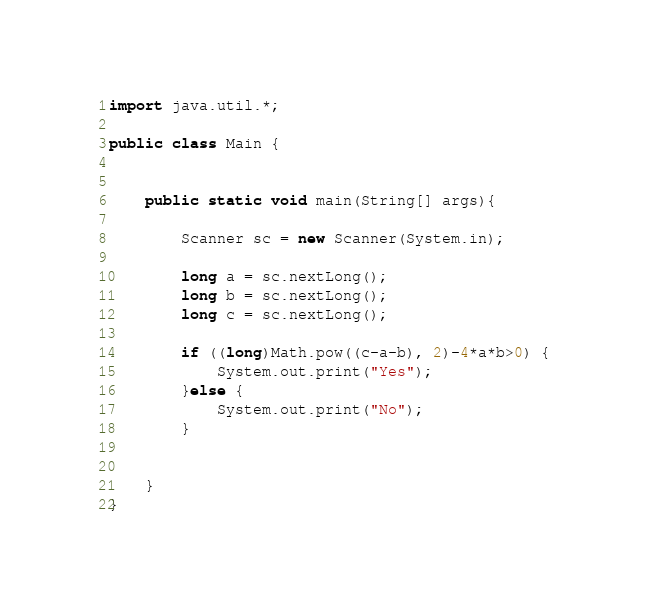<code> <loc_0><loc_0><loc_500><loc_500><_Java_>import java.util.*;

public class Main {


    public static void main(String[] args){

        Scanner sc = new Scanner(System.in);

        long a = sc.nextLong();
        long b = sc.nextLong();
        long c = sc.nextLong();

        if ((long)Math.pow((c-a-b), 2)-4*a*b>0) {
            System.out.print("Yes");
        }else {
            System.out.print("No");
        }


    }
}

</code> 